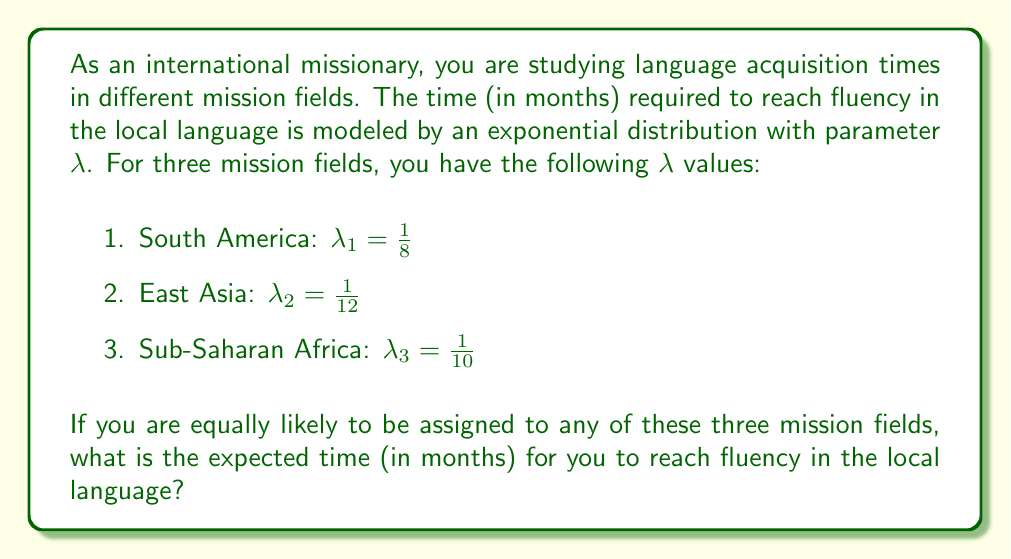Could you help me with this problem? Let's approach this step-by-step:

1) For an exponential distribution with parameter $\lambda$, the expected value (mean) is given by:

   $E[X] = \frac{1}{\lambda}$

2) For each mission field, we can calculate the expected time:

   South America: $E[X_1] = \frac{1}{\lambda_1} = \frac{1}{1/8} = 8$ months
   East Asia: $E[X_2] = \frac{1}{\lambda_2} = \frac{1}{1/12} = 12$ months
   Sub-Saharan Africa: $E[X_3] = \frac{1}{\lambda_3} = \frac{1}{1/10} = 10$ months

3) Since you are equally likely to be assigned to any of these fields, we can model this as a discrete uniform distribution over these three outcomes.

4) The expected value of a discrete uniform distribution is the average of all possible outcomes. Therefore, the overall expected time is:

   $E[X] = \frac{E[X_1] + E[X_2] + E[X_3]}{3}$

5) Substituting the values:

   $E[X] = \frac{8 + 12 + 10}{3} = \frac{30}{3} = 10$ months

Thus, the expected time to reach fluency is 10 months.
Answer: 10 months 